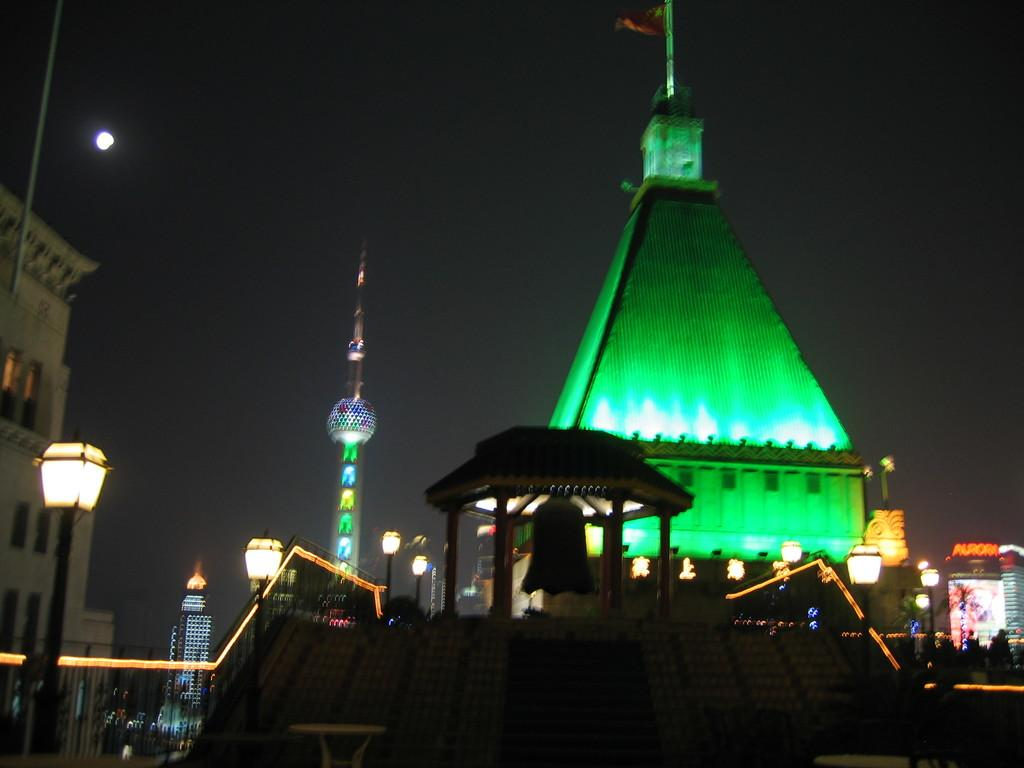What type of structure is present in the image? There is a building in the image. What can be observed about the lighting inside the building? The building has green color light inside. Where is the light pole located in the image? The light pole is on the left side of the image. Can you describe another building in the image? There is a cream color building in the image. What is the color of the background in the image? The background of the image is in black color. Who is the manager of the building in the image? There is no information about a manager in the image. What type of scissors can be seen cutting the building in the image? There are no scissors present in the image, and the building is not being cut. 